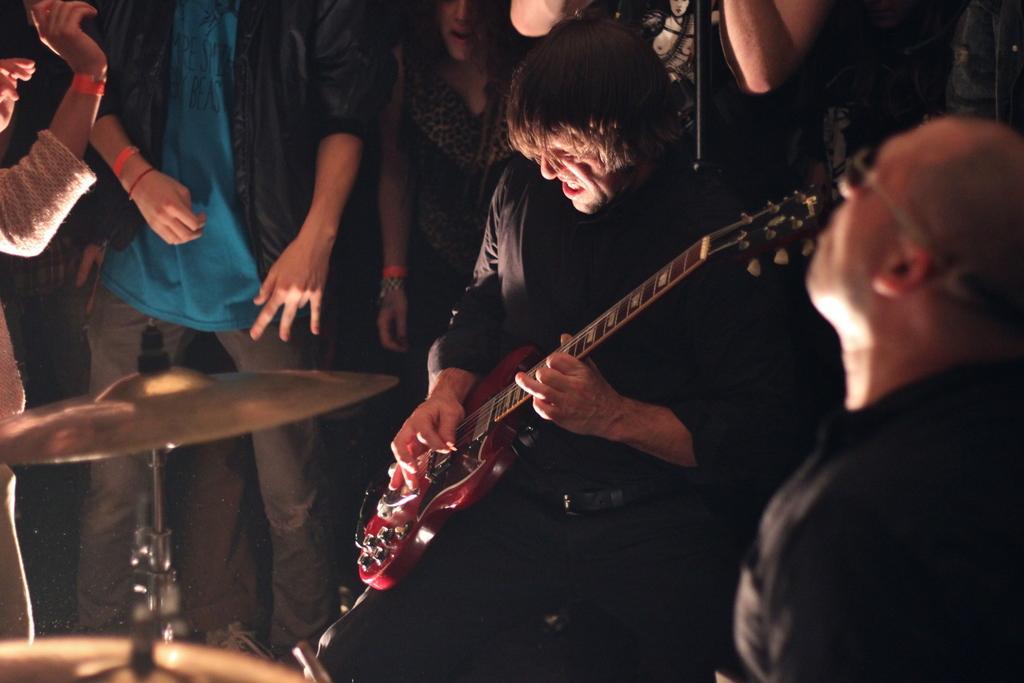Describe this image in one or two sentences. In this image there are group of persons who are standing around the person who is playing musical instrument. 